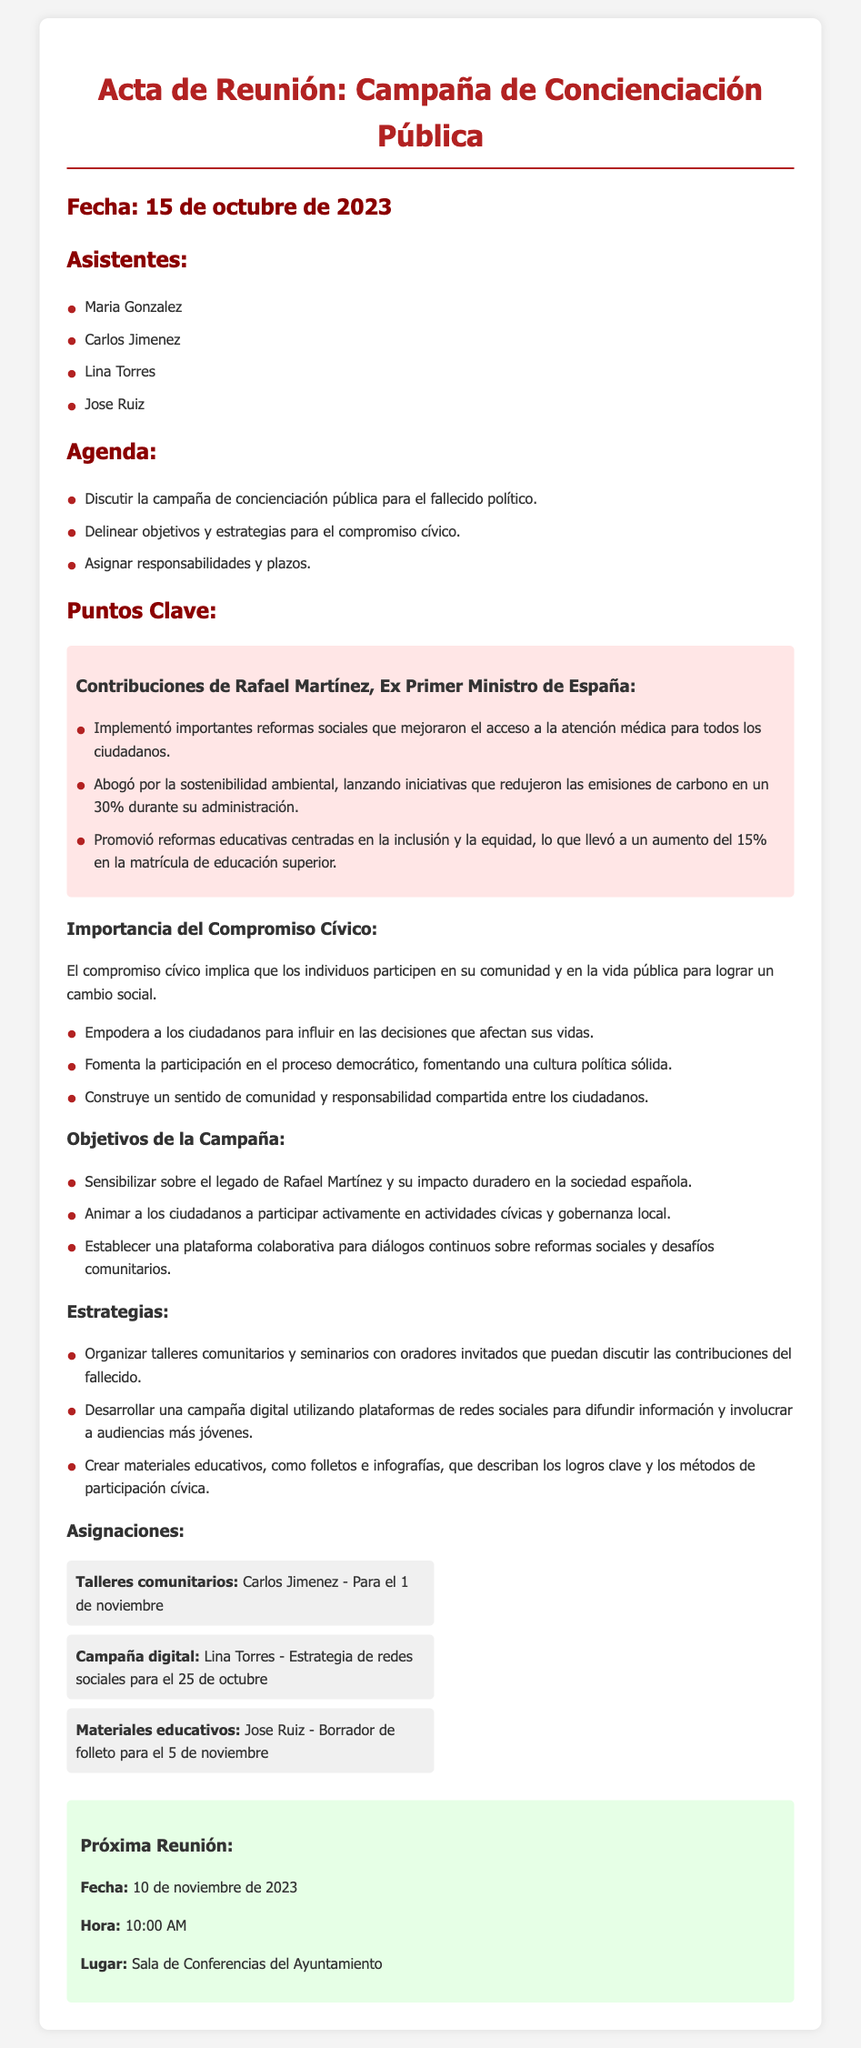¿Cuándo se llevó a cabo la reunión? La fecha de la reunión se menciona al principio del documento.
Answer: 15 de octubre de 2023 ¿Quién es el ex Primer Ministro de España mencionado en la reunión? El documento menciona a Rafael Martínez como el ex Primer Ministro y se enfoca en sus contribuciones.
Answer: Rafael Martínez ¿Cuál es uno de los objetivos de la campaña? La sección que detalla los objetivos de la campaña incluye este tipo de información.
Answer: Sensibilizar sobre el legado de Rafael Martínez ¿Qué estrategia se utilizará para involucrar a audiencias más jóvenes? Las estrategias se enumeran en una sección que detalla los métodos propuestos para la campaña.
Answer: Campaña digital ¿Cuál es la fecha de la próxima reunión? La fecha de la próxima reunión se indica al final del documento.
Answer: 10 de noviembre de 2023 ¿Cuál es el nombre de la persona que asignó los talleres comunitarios? La sección de asignaciones menciona quién es responsable de cada tarea específica.
Answer: Carlos Jimenez ¿Qué iniciativa promovió Rafael Martínez relacionada con el medio ambiente? La descripción de las contribuciones de Rafael Martínez incluye esta información en la sección de Contribuciones.
Answer: Iniciativas que redujeron las emisiones de carbono ¿Cuántas personas asistieron a la reunión? La lista de asistentes al principio proporciona este dato.
Answer: Cuatro 